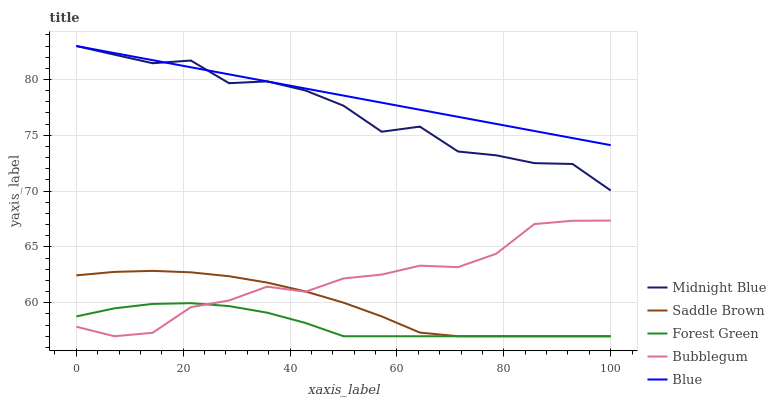Does Forest Green have the minimum area under the curve?
Answer yes or no. Yes. Does Blue have the maximum area under the curve?
Answer yes or no. Yes. Does Midnight Blue have the minimum area under the curve?
Answer yes or no. No. Does Midnight Blue have the maximum area under the curve?
Answer yes or no. No. Is Blue the smoothest?
Answer yes or no. Yes. Is Midnight Blue the roughest?
Answer yes or no. Yes. Is Forest Green the smoothest?
Answer yes or no. No. Is Forest Green the roughest?
Answer yes or no. No. Does Forest Green have the lowest value?
Answer yes or no. Yes. Does Midnight Blue have the lowest value?
Answer yes or no. No. Does Midnight Blue have the highest value?
Answer yes or no. Yes. Does Forest Green have the highest value?
Answer yes or no. No. Is Saddle Brown less than Midnight Blue?
Answer yes or no. Yes. Is Blue greater than Forest Green?
Answer yes or no. Yes. Does Midnight Blue intersect Blue?
Answer yes or no. Yes. Is Midnight Blue less than Blue?
Answer yes or no. No. Is Midnight Blue greater than Blue?
Answer yes or no. No. Does Saddle Brown intersect Midnight Blue?
Answer yes or no. No. 